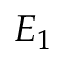<formula> <loc_0><loc_0><loc_500><loc_500>E _ { 1 }</formula> 